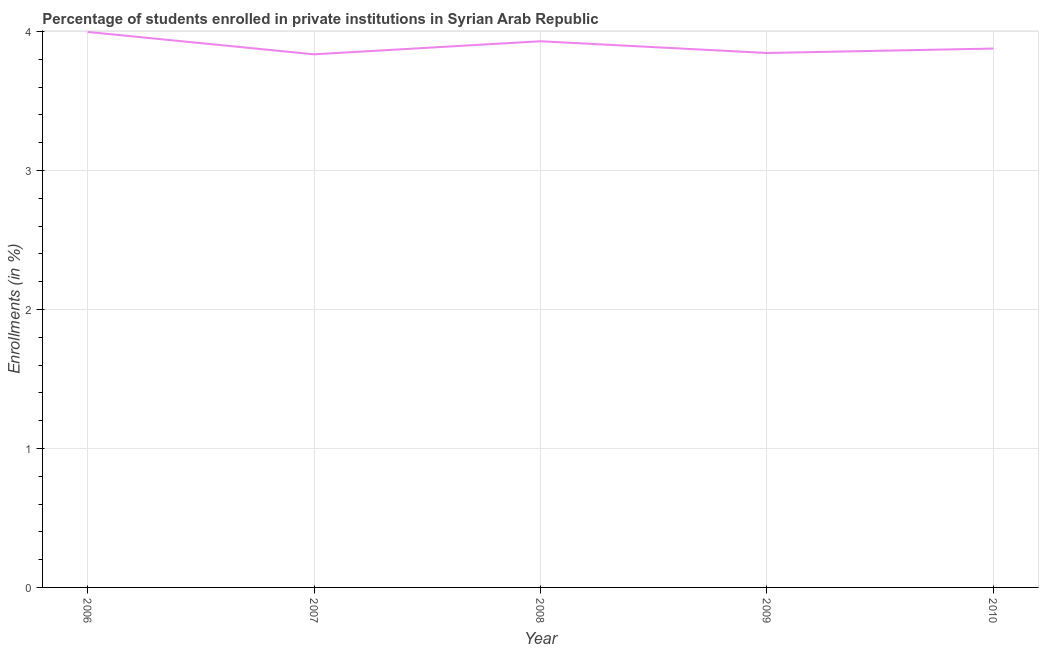What is the enrollments in private institutions in 2007?
Give a very brief answer. 3.84. Across all years, what is the maximum enrollments in private institutions?
Keep it short and to the point. 4. Across all years, what is the minimum enrollments in private institutions?
Ensure brevity in your answer.  3.84. What is the sum of the enrollments in private institutions?
Your answer should be compact. 19.49. What is the difference between the enrollments in private institutions in 2006 and 2008?
Keep it short and to the point. 0.07. What is the average enrollments in private institutions per year?
Give a very brief answer. 3.9. What is the median enrollments in private institutions?
Your answer should be very brief. 3.88. In how many years, is the enrollments in private institutions greater than 2.6 %?
Provide a short and direct response. 5. What is the ratio of the enrollments in private institutions in 2006 to that in 2007?
Your response must be concise. 1.04. Is the enrollments in private institutions in 2008 less than that in 2009?
Offer a terse response. No. Is the difference between the enrollments in private institutions in 2008 and 2010 greater than the difference between any two years?
Offer a terse response. No. What is the difference between the highest and the second highest enrollments in private institutions?
Provide a succinct answer. 0.07. Is the sum of the enrollments in private institutions in 2006 and 2007 greater than the maximum enrollments in private institutions across all years?
Provide a short and direct response. Yes. What is the difference between the highest and the lowest enrollments in private institutions?
Offer a very short reply. 0.16. In how many years, is the enrollments in private institutions greater than the average enrollments in private institutions taken over all years?
Provide a succinct answer. 2. What is the difference between two consecutive major ticks on the Y-axis?
Provide a succinct answer. 1. Does the graph contain grids?
Provide a short and direct response. Yes. What is the title of the graph?
Your answer should be compact. Percentage of students enrolled in private institutions in Syrian Arab Republic. What is the label or title of the Y-axis?
Offer a terse response. Enrollments (in %). What is the Enrollments (in %) in 2006?
Provide a short and direct response. 4. What is the Enrollments (in %) of 2007?
Keep it short and to the point. 3.84. What is the Enrollments (in %) of 2008?
Your answer should be compact. 3.93. What is the Enrollments (in %) of 2009?
Keep it short and to the point. 3.85. What is the Enrollments (in %) in 2010?
Provide a succinct answer. 3.88. What is the difference between the Enrollments (in %) in 2006 and 2007?
Your answer should be compact. 0.16. What is the difference between the Enrollments (in %) in 2006 and 2008?
Make the answer very short. 0.07. What is the difference between the Enrollments (in %) in 2006 and 2009?
Keep it short and to the point. 0.15. What is the difference between the Enrollments (in %) in 2006 and 2010?
Make the answer very short. 0.12. What is the difference between the Enrollments (in %) in 2007 and 2008?
Your response must be concise. -0.09. What is the difference between the Enrollments (in %) in 2007 and 2009?
Offer a terse response. -0.01. What is the difference between the Enrollments (in %) in 2007 and 2010?
Make the answer very short. -0.04. What is the difference between the Enrollments (in %) in 2008 and 2009?
Ensure brevity in your answer.  0.08. What is the difference between the Enrollments (in %) in 2008 and 2010?
Give a very brief answer. 0.05. What is the difference between the Enrollments (in %) in 2009 and 2010?
Provide a short and direct response. -0.03. What is the ratio of the Enrollments (in %) in 2006 to that in 2007?
Give a very brief answer. 1.04. What is the ratio of the Enrollments (in %) in 2006 to that in 2008?
Make the answer very short. 1.02. What is the ratio of the Enrollments (in %) in 2006 to that in 2009?
Offer a very short reply. 1.04. What is the ratio of the Enrollments (in %) in 2006 to that in 2010?
Make the answer very short. 1.03. What is the ratio of the Enrollments (in %) in 2007 to that in 2008?
Your answer should be compact. 0.98. What is the ratio of the Enrollments (in %) in 2007 to that in 2010?
Your answer should be compact. 0.99. 